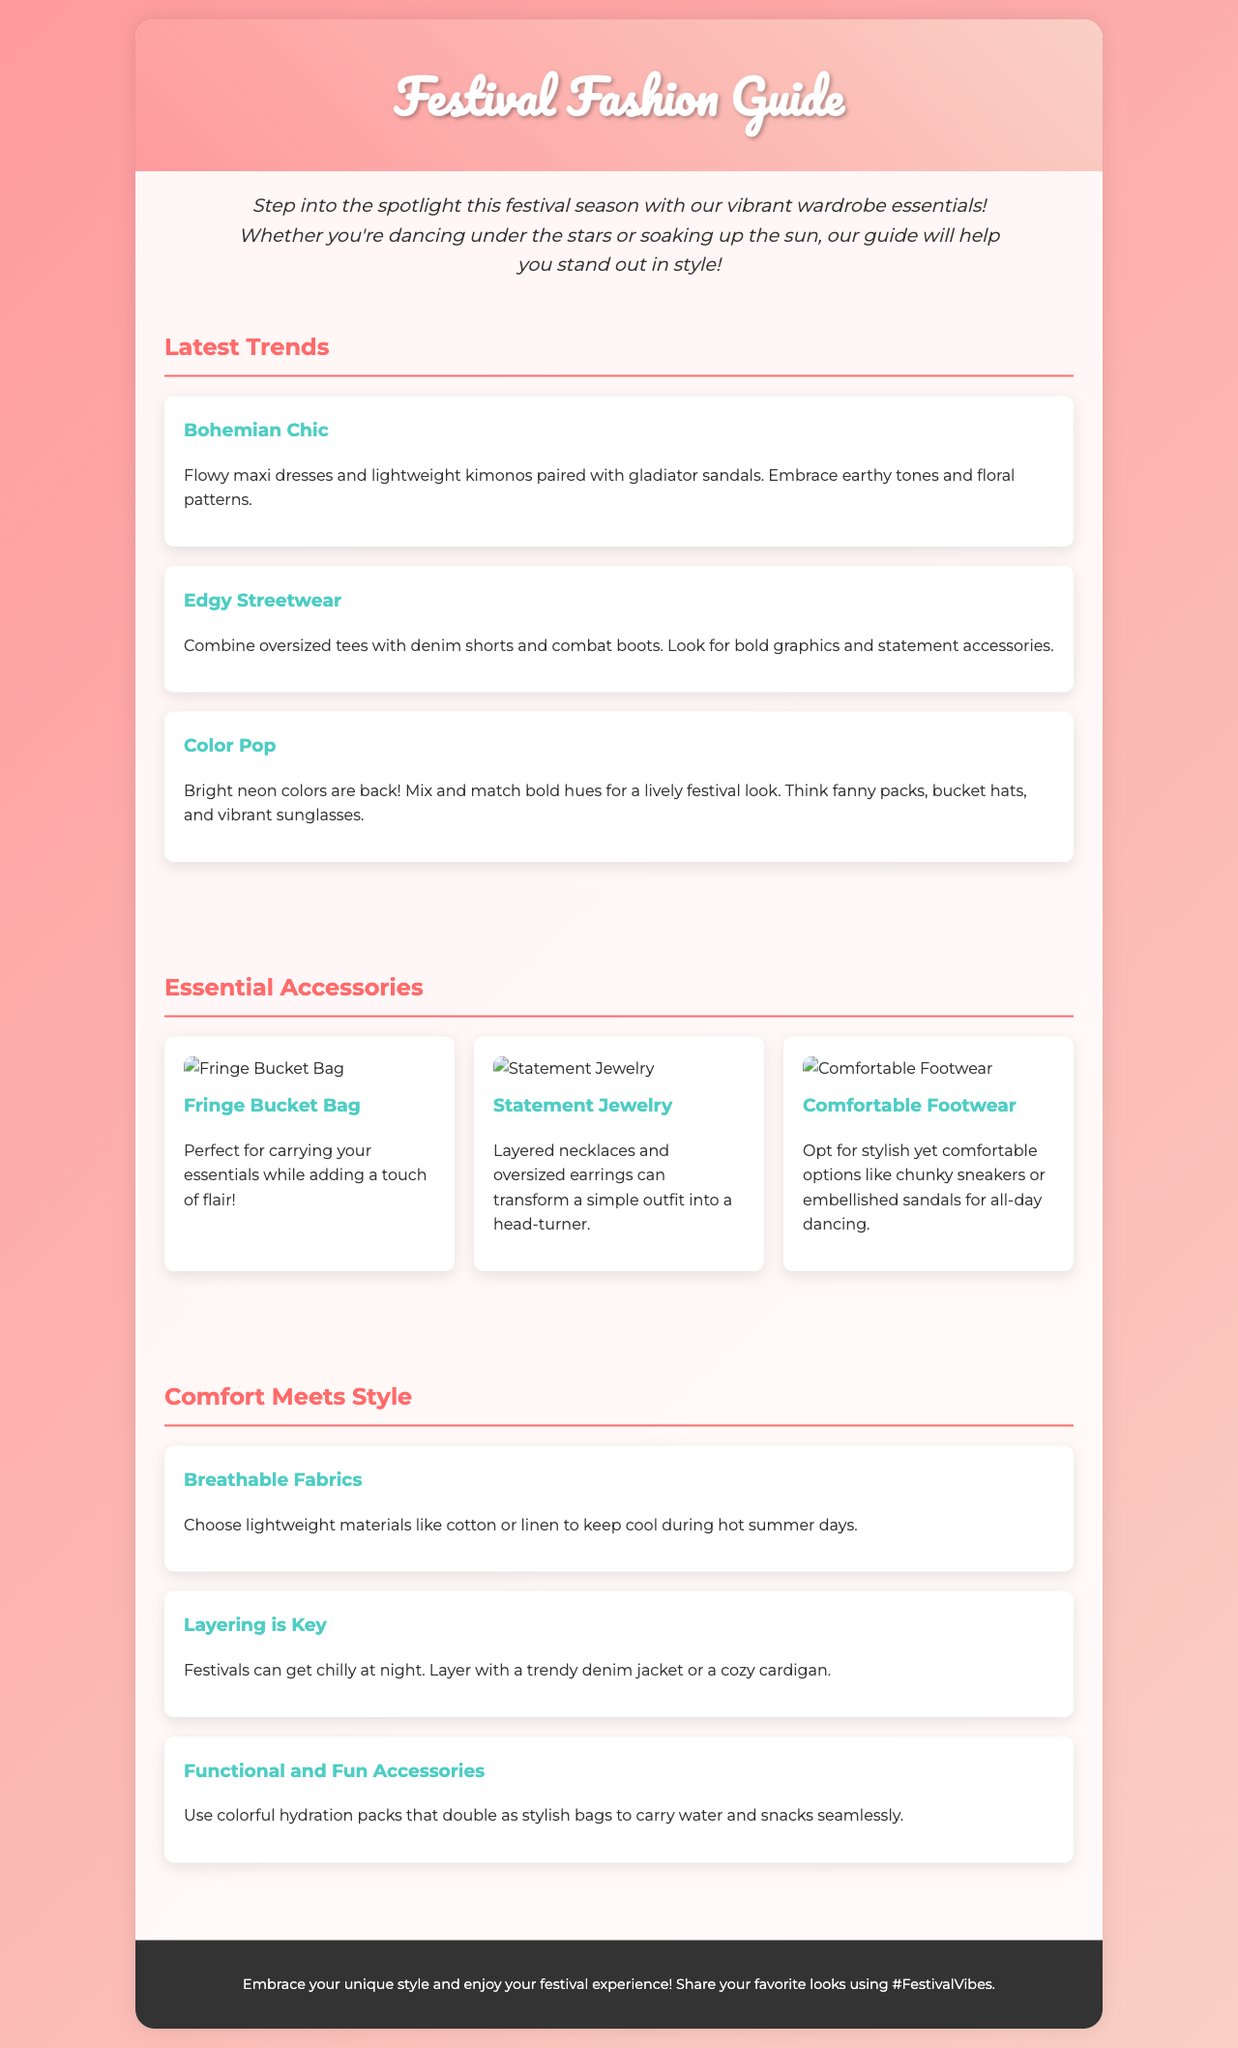What is the title of the brochure? The title is displayed prominently at the top of the document, indicating the subject focus of the content.
Answer: Festival Fashion Guide What is a suggested trend mentioned in the document? The document lists multiple trends; one specifically highlights a style that combines certain clothing elements and themes.
Answer: Bohemian Chic What type of footwear is recommended for festivals? The text provides insights into suitable footwear options for comfort during events.
Answer: Comfortable Footwear What color trend is mentioned for accessories? This detail pertains to the vibrant color palette that is suggested for festival fashion and accessories.
Answer: Neon colors What should you consider for nighttime at festivals? This suggestion is aimed at maintaining comfort and style as temperatures drop during the evening hours.
Answer: Layering What kind of materials should be chosen for hot days? The document advises on suitable fabric choices to stay cool during outdoor events.
Answer: Lightweight materials What hashtag is encouraged for sharing festival looks? The brochure includes a social media aspect to encourage viewers to engage by sharing their fashion choices.
Answer: #FestivalVibes What is one essential accessory listed? One key accessory is highlighted for both functionality and style while attending festivals.
Answer: Statement Jewelry 